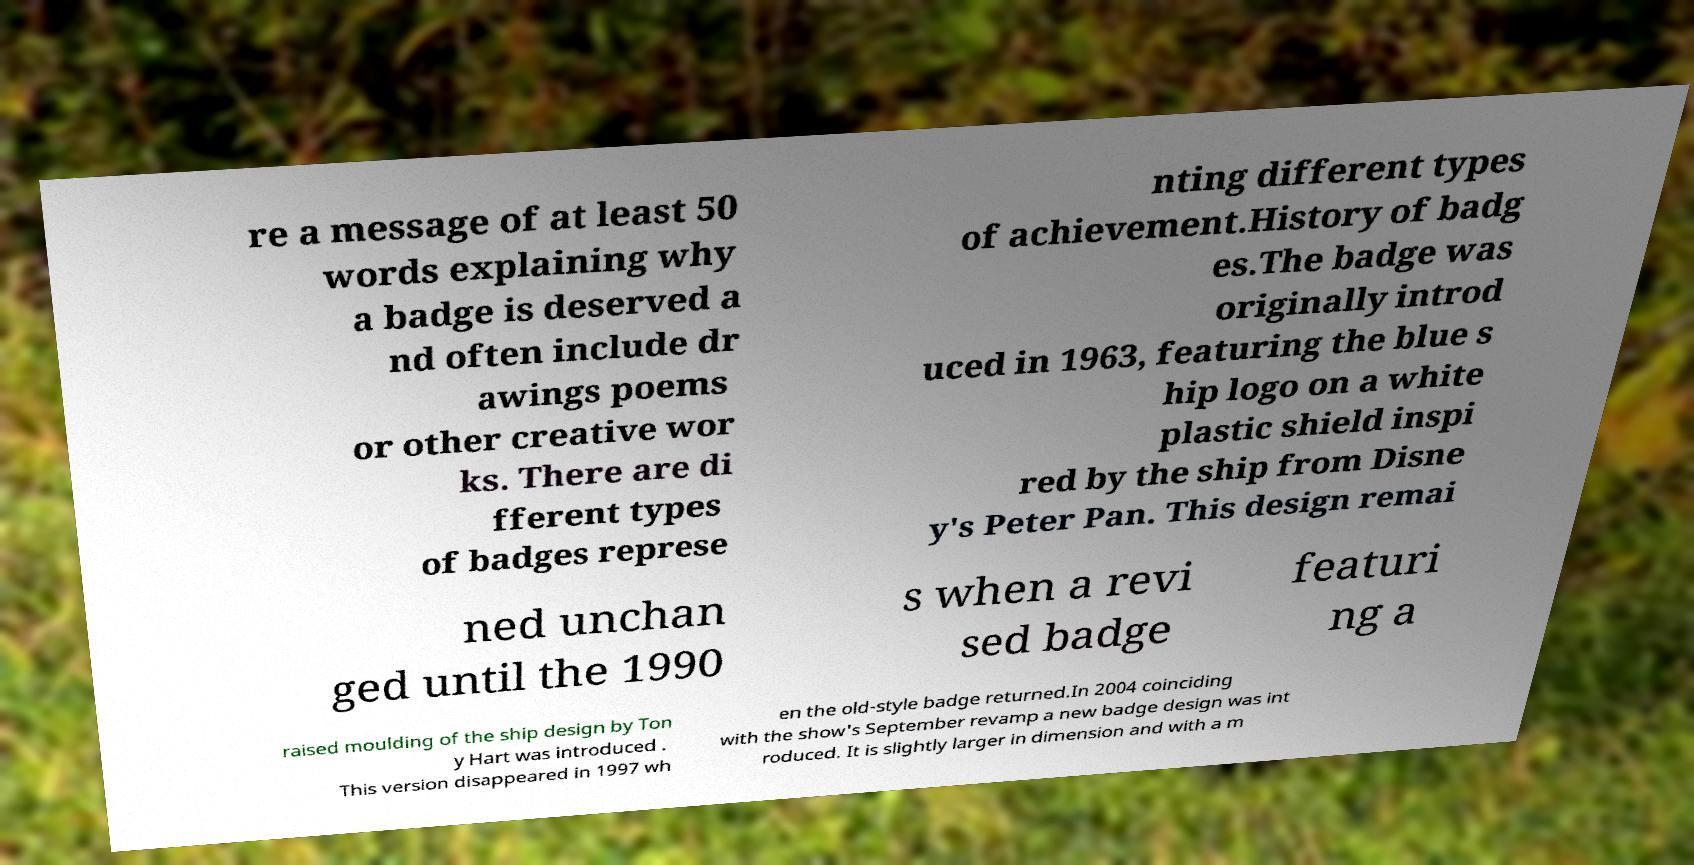Can you read and provide the text displayed in the image?This photo seems to have some interesting text. Can you extract and type it out for me? re a message of at least 50 words explaining why a badge is deserved a nd often include dr awings poems or other creative wor ks. There are di fferent types of badges represe nting different types of achievement.History of badg es.The badge was originally introd uced in 1963, featuring the blue s hip logo on a white plastic shield inspi red by the ship from Disne y's Peter Pan. This design remai ned unchan ged until the 1990 s when a revi sed badge featuri ng a raised moulding of the ship design by Ton y Hart was introduced . This version disappeared in 1997 wh en the old-style badge returned.In 2004 coinciding with the show's September revamp a new badge design was int roduced. It is slightly larger in dimension and with a m 